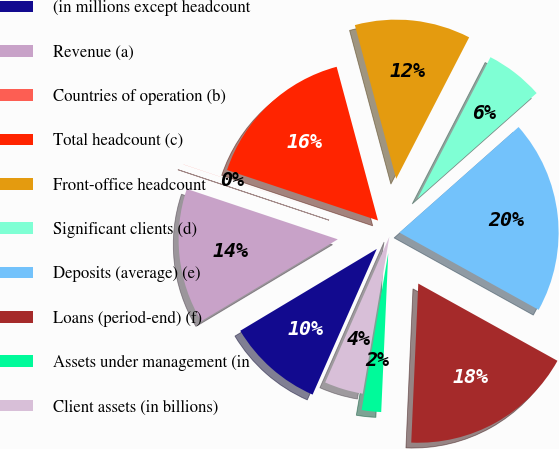Convert chart to OTSL. <chart><loc_0><loc_0><loc_500><loc_500><pie_chart><fcel>(in millions except headcount<fcel>Revenue (a)<fcel>Countries of operation (b)<fcel>Total headcount (c)<fcel>Front-office headcount<fcel>Significant clients (d)<fcel>Deposits (average) (e)<fcel>Loans (period-end) (f)<fcel>Assets under management (in<fcel>Client assets (in billions)<nl><fcel>9.8%<fcel>13.72%<fcel>0.01%<fcel>15.68%<fcel>11.76%<fcel>5.88%<fcel>19.6%<fcel>17.64%<fcel>1.97%<fcel>3.93%<nl></chart> 